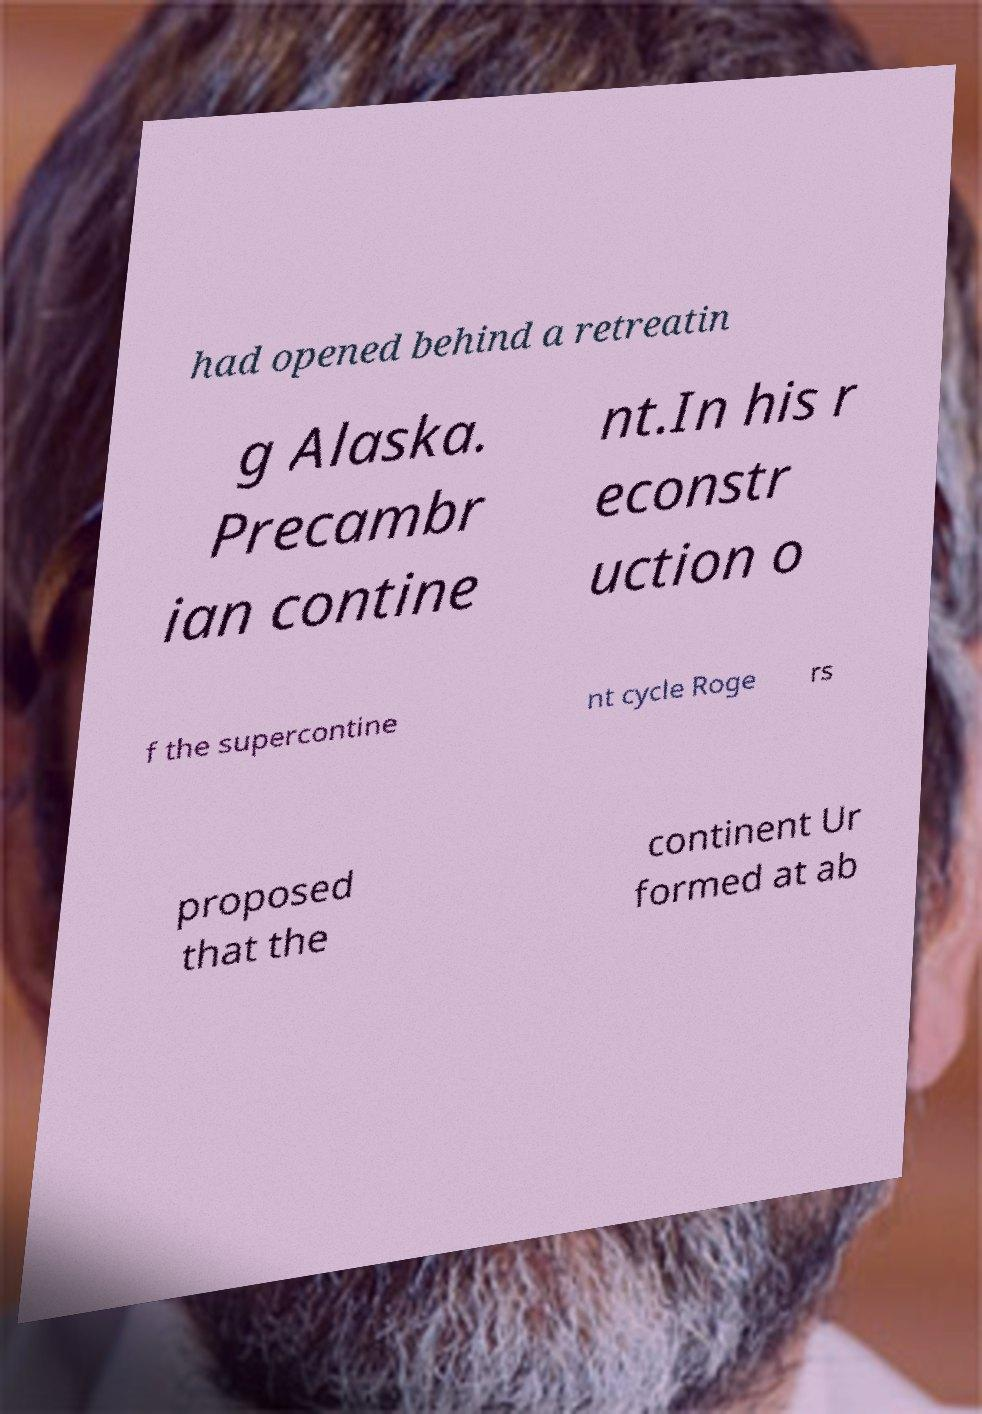For documentation purposes, I need the text within this image transcribed. Could you provide that? had opened behind a retreatin g Alaska. Precambr ian contine nt.In his r econstr uction o f the supercontine nt cycle Roge rs proposed that the continent Ur formed at ab 